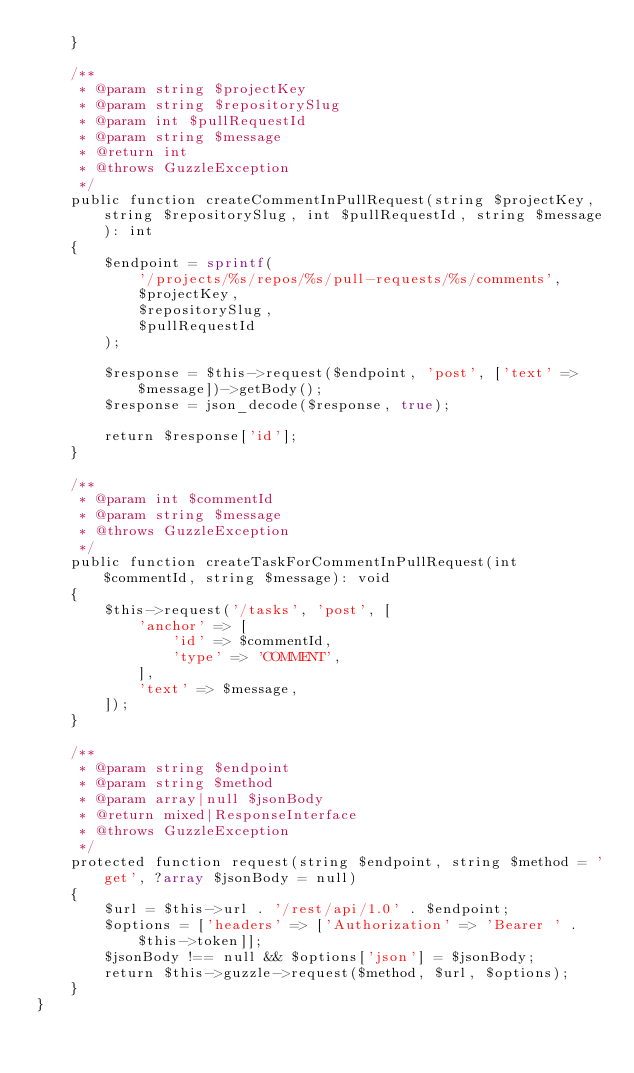Convert code to text. <code><loc_0><loc_0><loc_500><loc_500><_PHP_>    }

    /**
     * @param string $projectKey
     * @param string $repositorySlug
     * @param int $pullRequestId
     * @param string $message
     * @return int
     * @throws GuzzleException
     */
    public function createCommentInPullRequest(string $projectKey, string $repositorySlug, int $pullRequestId, string $message): int
    {
        $endpoint = sprintf(
            '/projects/%s/repos/%s/pull-requests/%s/comments',
            $projectKey,
            $repositorySlug,
            $pullRequestId
        );

        $response = $this->request($endpoint, 'post', ['text' => $message])->getBody();
        $response = json_decode($response, true);

        return $response['id'];
    }

    /**
     * @param int $commentId
     * @param string $message
     * @throws GuzzleException
     */
    public function createTaskForCommentInPullRequest(int $commentId, string $message): void
    {
        $this->request('/tasks', 'post', [
            'anchor' => [
                'id' => $commentId,
                'type' => 'COMMENT',
            ],
            'text' => $message,
        ]);
    }

    /**
     * @param string $endpoint
     * @param string $method
     * @param array|null $jsonBody
     * @return mixed|ResponseInterface
     * @throws GuzzleException
     */
    protected function request(string $endpoint, string $method = 'get', ?array $jsonBody = null)
    {
        $url = $this->url . '/rest/api/1.0' . $endpoint;
        $options = ['headers' => ['Authorization' => 'Bearer ' . $this->token]];
        $jsonBody !== null && $options['json'] = $jsonBody;
        return $this->guzzle->request($method, $url, $options);
    }
}
</code> 